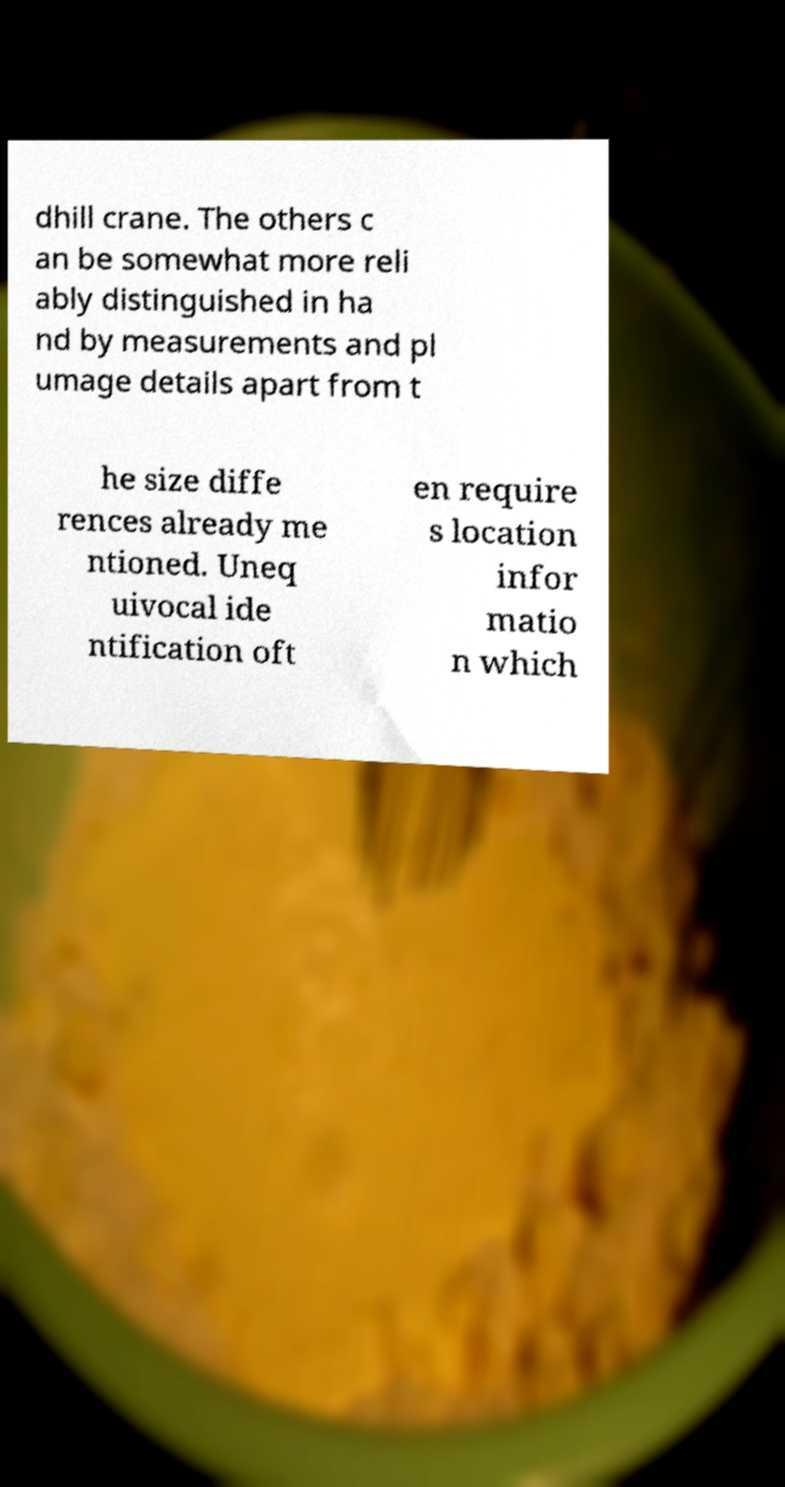Could you extract and type out the text from this image? dhill crane. The others c an be somewhat more reli ably distinguished in ha nd by measurements and pl umage details apart from t he size diffe rences already me ntioned. Uneq uivocal ide ntification oft en require s location infor matio n which 